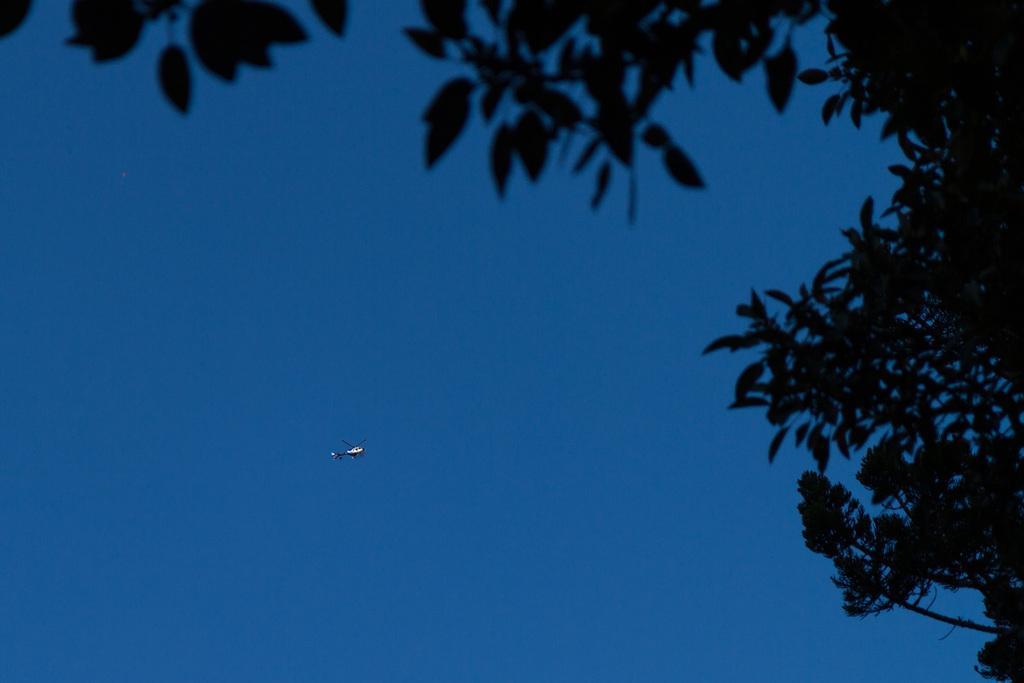Could you give a brief overview of what you see in this image? In the helicopter is flying in the sky, these are the trees in this image. 